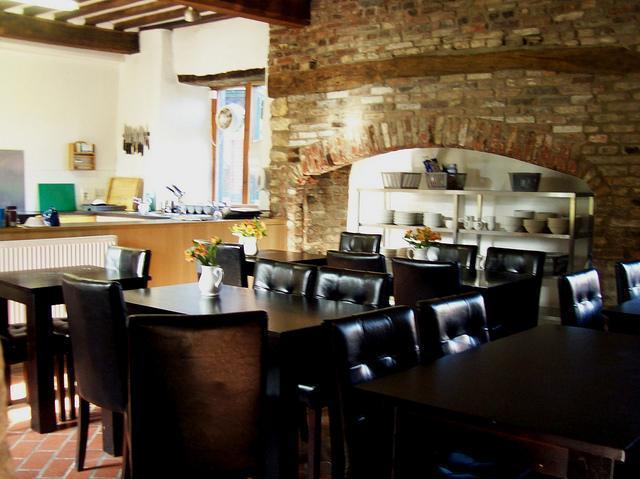How many chairs are in the picture?
Give a very brief answer. 7. How many dining tables are in the photo?
Give a very brief answer. 2. How many trees to the left of the giraffe are there?
Give a very brief answer. 0. 